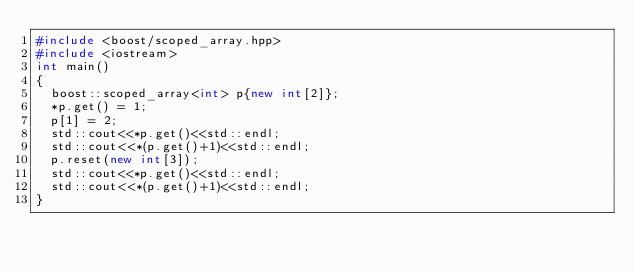<code> <loc_0><loc_0><loc_500><loc_500><_C++_>#include <boost/scoped_array.hpp>
#include <iostream>
int main()
{
  boost::scoped_array<int> p{new int[2]};
  *p.get() = 1;
  p[1] = 2;
  std::cout<<*p.get()<<std::endl;
  std::cout<<*(p.get()+1)<<std::endl;
  p.reset(new int[3]);
  std::cout<<*p.get()<<std::endl;
  std::cout<<*(p.get()+1)<<std::endl;
}
</code> 